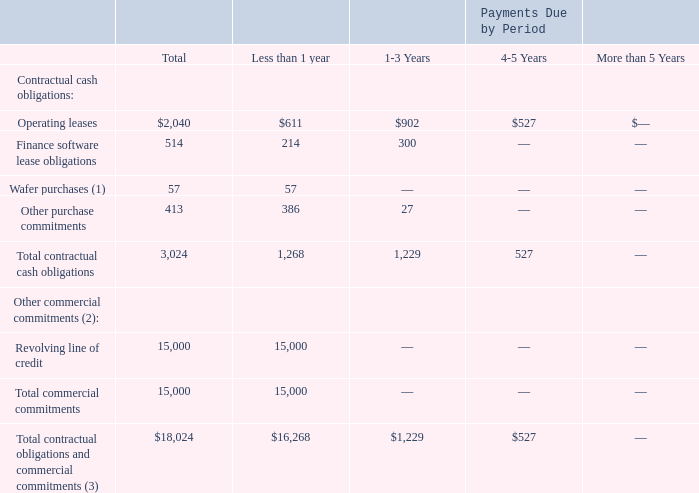Contractual Obligations and Commercial Commitments
The following table summarizes our non-cancelable contractual obligations and commercial commitments as of the end of 2019 and the effect such obligations and commitments are expected to have on our liquidity and cash flows in future fiscal periods (in thousands):
(1) Certain of our wafer manufacturers require us to forecast wafer starts several months in advance. We are committed to take delivery of and pay for a portion of forecasted wafer volume.
(2) Other commercial commitments are included as liabilities on our consolidated balance sheets as of the end of 2019.
(3) Does not include unrecognized tax benefits of $2.1 million as of the end of 2019. See Note 10 of the Consolidated Financial Statements.
What are the respective values of operating leases due in less than 1 year and between 1 to 3 years?
Answer scale should be: thousand. $611, $902. What are the respective values of finance software lease obligations due in less than 1 year and between 1 to 3 years?
Answer scale should be: thousand. 214, 300. What are the respective values of the company's total contractual cash obligations due in less than 1 year and between 1 to 3 years?
Answer scale should be: thousand. 1,268, 1,229. What is the average operating leases due in less than 1 year and between 1 to 3 years?
Answer scale should be: thousand. ($611 + $902)/2 
Answer: 756.5. What is the average finance software lease obligations due in less than 1 year and between 1 to 3 years?
Answer scale should be: thousand. (214 + 300)/2 
Answer: 257. What is the average  total contractual cash obligations due in less than 1 year and between 1 to 3 years?
Answer scale should be: thousand. (1,268 + 1,229)/2 
Answer: 1248.5. 